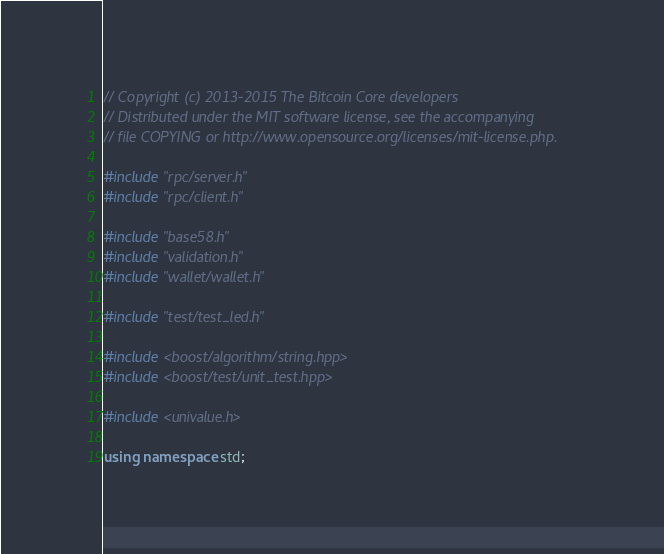Convert code to text. <code><loc_0><loc_0><loc_500><loc_500><_C++_>// Copyright (c) 2013-2015 The Bitcoin Core developers
// Distributed under the MIT software license, see the accompanying
// file COPYING or http://www.opensource.org/licenses/mit-license.php.

#include "rpc/server.h"
#include "rpc/client.h"

#include "base58.h"
#include "validation.h"
#include "wallet/wallet.h"

#include "test/test_led.h"

#include <boost/algorithm/string.hpp>
#include <boost/test/unit_test.hpp>

#include <univalue.h>

using namespace std;
</code> 